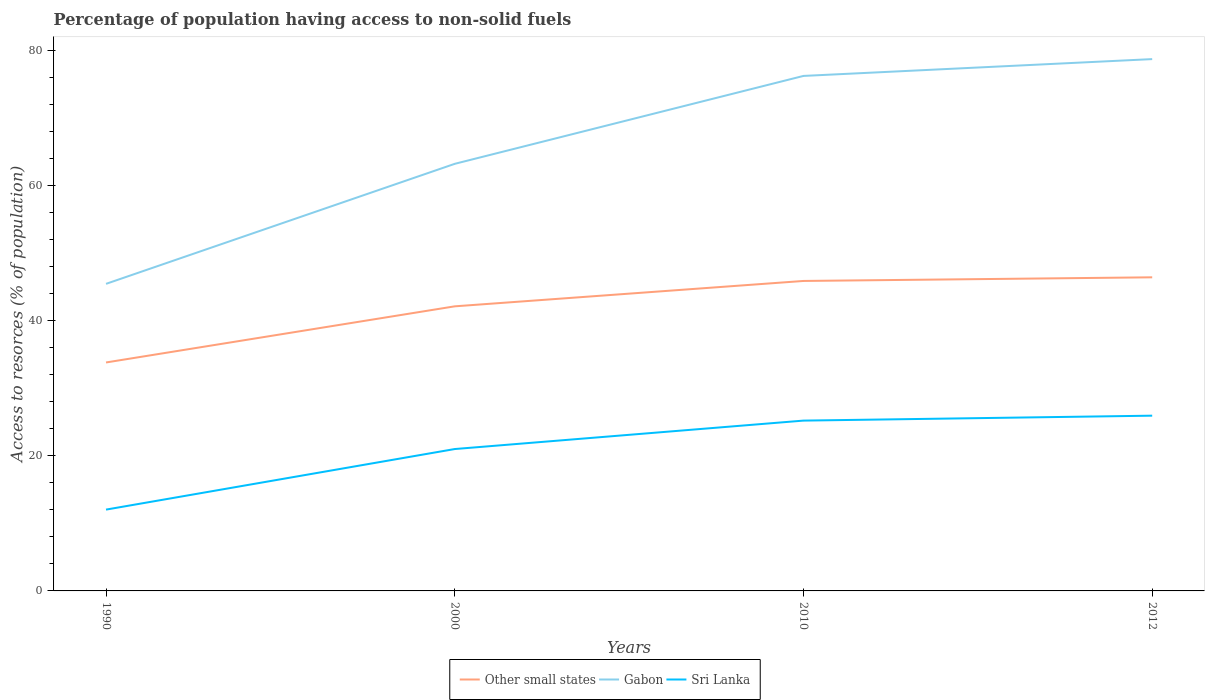How many different coloured lines are there?
Provide a succinct answer. 3. Does the line corresponding to Sri Lanka intersect with the line corresponding to Gabon?
Provide a succinct answer. No. Is the number of lines equal to the number of legend labels?
Offer a terse response. Yes. Across all years, what is the maximum percentage of population having access to non-solid fuels in Gabon?
Offer a very short reply. 45.43. In which year was the percentage of population having access to non-solid fuels in Other small states maximum?
Ensure brevity in your answer.  1990. What is the total percentage of population having access to non-solid fuels in Sri Lanka in the graph?
Provide a short and direct response. -4.94. What is the difference between the highest and the second highest percentage of population having access to non-solid fuels in Sri Lanka?
Provide a short and direct response. 13.9. What is the difference between the highest and the lowest percentage of population having access to non-solid fuels in Sri Lanka?
Offer a very short reply. 2. What is the difference between two consecutive major ticks on the Y-axis?
Give a very brief answer. 20. Are the values on the major ticks of Y-axis written in scientific E-notation?
Provide a short and direct response. No. Does the graph contain any zero values?
Your answer should be very brief. No. How many legend labels are there?
Offer a very short reply. 3. What is the title of the graph?
Offer a very short reply. Percentage of population having access to non-solid fuels. Does "Jordan" appear as one of the legend labels in the graph?
Your response must be concise. No. What is the label or title of the X-axis?
Offer a terse response. Years. What is the label or title of the Y-axis?
Offer a very short reply. Access to resorces (% of population). What is the Access to resorces (% of population) of Other small states in 1990?
Offer a terse response. 33.8. What is the Access to resorces (% of population) in Gabon in 1990?
Give a very brief answer. 45.43. What is the Access to resorces (% of population) in Sri Lanka in 1990?
Your answer should be compact. 12.03. What is the Access to resorces (% of population) of Other small states in 2000?
Ensure brevity in your answer.  42.11. What is the Access to resorces (% of population) of Gabon in 2000?
Your answer should be compact. 63.19. What is the Access to resorces (% of population) of Sri Lanka in 2000?
Offer a very short reply. 20.99. What is the Access to resorces (% of population) in Other small states in 2010?
Your answer should be compact. 45.86. What is the Access to resorces (% of population) in Gabon in 2010?
Keep it short and to the point. 76.19. What is the Access to resorces (% of population) of Sri Lanka in 2010?
Give a very brief answer. 25.2. What is the Access to resorces (% of population) of Other small states in 2012?
Keep it short and to the point. 46.4. What is the Access to resorces (% of population) in Gabon in 2012?
Ensure brevity in your answer.  78.68. What is the Access to resorces (% of population) of Sri Lanka in 2012?
Provide a succinct answer. 25.93. Across all years, what is the maximum Access to resorces (% of population) of Other small states?
Your response must be concise. 46.4. Across all years, what is the maximum Access to resorces (% of population) in Gabon?
Provide a succinct answer. 78.68. Across all years, what is the maximum Access to resorces (% of population) in Sri Lanka?
Provide a short and direct response. 25.93. Across all years, what is the minimum Access to resorces (% of population) in Other small states?
Offer a terse response. 33.8. Across all years, what is the minimum Access to resorces (% of population) of Gabon?
Your answer should be very brief. 45.43. Across all years, what is the minimum Access to resorces (% of population) of Sri Lanka?
Your answer should be compact. 12.03. What is the total Access to resorces (% of population) of Other small states in the graph?
Provide a short and direct response. 168.16. What is the total Access to resorces (% of population) of Gabon in the graph?
Offer a very short reply. 263.49. What is the total Access to resorces (% of population) in Sri Lanka in the graph?
Ensure brevity in your answer.  84.15. What is the difference between the Access to resorces (% of population) in Other small states in 1990 and that in 2000?
Your answer should be very brief. -8.31. What is the difference between the Access to resorces (% of population) of Gabon in 1990 and that in 2000?
Provide a succinct answer. -17.76. What is the difference between the Access to resorces (% of population) of Sri Lanka in 1990 and that in 2000?
Offer a terse response. -8.96. What is the difference between the Access to resorces (% of population) of Other small states in 1990 and that in 2010?
Give a very brief answer. -12.06. What is the difference between the Access to resorces (% of population) in Gabon in 1990 and that in 2010?
Give a very brief answer. -30.76. What is the difference between the Access to resorces (% of population) of Sri Lanka in 1990 and that in 2010?
Give a very brief answer. -13.17. What is the difference between the Access to resorces (% of population) of Other small states in 1990 and that in 2012?
Offer a terse response. -12.6. What is the difference between the Access to resorces (% of population) in Gabon in 1990 and that in 2012?
Offer a very short reply. -33.25. What is the difference between the Access to resorces (% of population) in Sri Lanka in 1990 and that in 2012?
Provide a succinct answer. -13.9. What is the difference between the Access to resorces (% of population) of Other small states in 2000 and that in 2010?
Keep it short and to the point. -3.75. What is the difference between the Access to resorces (% of population) in Gabon in 2000 and that in 2010?
Keep it short and to the point. -13.01. What is the difference between the Access to resorces (% of population) in Sri Lanka in 2000 and that in 2010?
Keep it short and to the point. -4.21. What is the difference between the Access to resorces (% of population) in Other small states in 2000 and that in 2012?
Ensure brevity in your answer.  -4.29. What is the difference between the Access to resorces (% of population) of Gabon in 2000 and that in 2012?
Offer a very short reply. -15.49. What is the difference between the Access to resorces (% of population) of Sri Lanka in 2000 and that in 2012?
Make the answer very short. -4.94. What is the difference between the Access to resorces (% of population) of Other small states in 2010 and that in 2012?
Keep it short and to the point. -0.54. What is the difference between the Access to resorces (% of population) in Gabon in 2010 and that in 2012?
Your answer should be compact. -2.49. What is the difference between the Access to resorces (% of population) in Sri Lanka in 2010 and that in 2012?
Keep it short and to the point. -0.73. What is the difference between the Access to resorces (% of population) in Other small states in 1990 and the Access to resorces (% of population) in Gabon in 2000?
Offer a very short reply. -29.39. What is the difference between the Access to resorces (% of population) in Other small states in 1990 and the Access to resorces (% of population) in Sri Lanka in 2000?
Make the answer very short. 12.81. What is the difference between the Access to resorces (% of population) of Gabon in 1990 and the Access to resorces (% of population) of Sri Lanka in 2000?
Ensure brevity in your answer.  24.44. What is the difference between the Access to resorces (% of population) in Other small states in 1990 and the Access to resorces (% of population) in Gabon in 2010?
Ensure brevity in your answer.  -42.39. What is the difference between the Access to resorces (% of population) of Other small states in 1990 and the Access to resorces (% of population) of Sri Lanka in 2010?
Offer a very short reply. 8.6. What is the difference between the Access to resorces (% of population) of Gabon in 1990 and the Access to resorces (% of population) of Sri Lanka in 2010?
Ensure brevity in your answer.  20.23. What is the difference between the Access to resorces (% of population) in Other small states in 1990 and the Access to resorces (% of population) in Gabon in 2012?
Provide a succinct answer. -44.88. What is the difference between the Access to resorces (% of population) of Other small states in 1990 and the Access to resorces (% of population) of Sri Lanka in 2012?
Make the answer very short. 7.87. What is the difference between the Access to resorces (% of population) of Gabon in 1990 and the Access to resorces (% of population) of Sri Lanka in 2012?
Provide a succinct answer. 19.5. What is the difference between the Access to resorces (% of population) of Other small states in 2000 and the Access to resorces (% of population) of Gabon in 2010?
Your answer should be compact. -34.09. What is the difference between the Access to resorces (% of population) in Other small states in 2000 and the Access to resorces (% of population) in Sri Lanka in 2010?
Provide a short and direct response. 16.91. What is the difference between the Access to resorces (% of population) in Gabon in 2000 and the Access to resorces (% of population) in Sri Lanka in 2010?
Ensure brevity in your answer.  37.99. What is the difference between the Access to resorces (% of population) in Other small states in 2000 and the Access to resorces (% of population) in Gabon in 2012?
Your answer should be very brief. -36.58. What is the difference between the Access to resorces (% of population) in Other small states in 2000 and the Access to resorces (% of population) in Sri Lanka in 2012?
Keep it short and to the point. 16.18. What is the difference between the Access to resorces (% of population) of Gabon in 2000 and the Access to resorces (% of population) of Sri Lanka in 2012?
Your response must be concise. 37.26. What is the difference between the Access to resorces (% of population) in Other small states in 2010 and the Access to resorces (% of population) in Gabon in 2012?
Provide a succinct answer. -32.82. What is the difference between the Access to resorces (% of population) in Other small states in 2010 and the Access to resorces (% of population) in Sri Lanka in 2012?
Offer a terse response. 19.93. What is the difference between the Access to resorces (% of population) in Gabon in 2010 and the Access to resorces (% of population) in Sri Lanka in 2012?
Provide a short and direct response. 50.26. What is the average Access to resorces (% of population) of Other small states per year?
Your answer should be very brief. 42.04. What is the average Access to resorces (% of population) in Gabon per year?
Give a very brief answer. 65.87. What is the average Access to resorces (% of population) of Sri Lanka per year?
Give a very brief answer. 21.04. In the year 1990, what is the difference between the Access to resorces (% of population) in Other small states and Access to resorces (% of population) in Gabon?
Ensure brevity in your answer.  -11.63. In the year 1990, what is the difference between the Access to resorces (% of population) of Other small states and Access to resorces (% of population) of Sri Lanka?
Offer a very short reply. 21.77. In the year 1990, what is the difference between the Access to resorces (% of population) in Gabon and Access to resorces (% of population) in Sri Lanka?
Provide a short and direct response. 33.4. In the year 2000, what is the difference between the Access to resorces (% of population) in Other small states and Access to resorces (% of population) in Gabon?
Provide a short and direct response. -21.08. In the year 2000, what is the difference between the Access to resorces (% of population) of Other small states and Access to resorces (% of population) of Sri Lanka?
Your answer should be very brief. 21.11. In the year 2000, what is the difference between the Access to resorces (% of population) in Gabon and Access to resorces (% of population) in Sri Lanka?
Keep it short and to the point. 42.2. In the year 2010, what is the difference between the Access to resorces (% of population) of Other small states and Access to resorces (% of population) of Gabon?
Ensure brevity in your answer.  -30.33. In the year 2010, what is the difference between the Access to resorces (% of population) of Other small states and Access to resorces (% of population) of Sri Lanka?
Offer a very short reply. 20.66. In the year 2010, what is the difference between the Access to resorces (% of population) of Gabon and Access to resorces (% of population) of Sri Lanka?
Provide a succinct answer. 50.99. In the year 2012, what is the difference between the Access to resorces (% of population) of Other small states and Access to resorces (% of population) of Gabon?
Offer a terse response. -32.28. In the year 2012, what is the difference between the Access to resorces (% of population) in Other small states and Access to resorces (% of population) in Sri Lanka?
Offer a terse response. 20.47. In the year 2012, what is the difference between the Access to resorces (% of population) in Gabon and Access to resorces (% of population) in Sri Lanka?
Ensure brevity in your answer.  52.75. What is the ratio of the Access to resorces (% of population) in Other small states in 1990 to that in 2000?
Provide a succinct answer. 0.8. What is the ratio of the Access to resorces (% of population) in Gabon in 1990 to that in 2000?
Keep it short and to the point. 0.72. What is the ratio of the Access to resorces (% of population) in Sri Lanka in 1990 to that in 2000?
Offer a very short reply. 0.57. What is the ratio of the Access to resorces (% of population) of Other small states in 1990 to that in 2010?
Keep it short and to the point. 0.74. What is the ratio of the Access to resorces (% of population) of Gabon in 1990 to that in 2010?
Provide a short and direct response. 0.6. What is the ratio of the Access to resorces (% of population) in Sri Lanka in 1990 to that in 2010?
Ensure brevity in your answer.  0.48. What is the ratio of the Access to resorces (% of population) in Other small states in 1990 to that in 2012?
Provide a succinct answer. 0.73. What is the ratio of the Access to resorces (% of population) in Gabon in 1990 to that in 2012?
Your answer should be compact. 0.58. What is the ratio of the Access to resorces (% of population) of Sri Lanka in 1990 to that in 2012?
Your answer should be compact. 0.46. What is the ratio of the Access to resorces (% of population) of Other small states in 2000 to that in 2010?
Offer a very short reply. 0.92. What is the ratio of the Access to resorces (% of population) in Gabon in 2000 to that in 2010?
Give a very brief answer. 0.83. What is the ratio of the Access to resorces (% of population) in Sri Lanka in 2000 to that in 2010?
Give a very brief answer. 0.83. What is the ratio of the Access to resorces (% of population) in Other small states in 2000 to that in 2012?
Give a very brief answer. 0.91. What is the ratio of the Access to resorces (% of population) in Gabon in 2000 to that in 2012?
Make the answer very short. 0.8. What is the ratio of the Access to resorces (% of population) of Sri Lanka in 2000 to that in 2012?
Offer a terse response. 0.81. What is the ratio of the Access to resorces (% of population) in Other small states in 2010 to that in 2012?
Keep it short and to the point. 0.99. What is the ratio of the Access to resorces (% of population) in Gabon in 2010 to that in 2012?
Your answer should be very brief. 0.97. What is the ratio of the Access to resorces (% of population) in Sri Lanka in 2010 to that in 2012?
Offer a terse response. 0.97. What is the difference between the highest and the second highest Access to resorces (% of population) in Other small states?
Provide a short and direct response. 0.54. What is the difference between the highest and the second highest Access to resorces (% of population) in Gabon?
Ensure brevity in your answer.  2.49. What is the difference between the highest and the second highest Access to resorces (% of population) of Sri Lanka?
Make the answer very short. 0.73. What is the difference between the highest and the lowest Access to resorces (% of population) of Other small states?
Make the answer very short. 12.6. What is the difference between the highest and the lowest Access to resorces (% of population) of Gabon?
Make the answer very short. 33.25. What is the difference between the highest and the lowest Access to resorces (% of population) in Sri Lanka?
Offer a terse response. 13.9. 